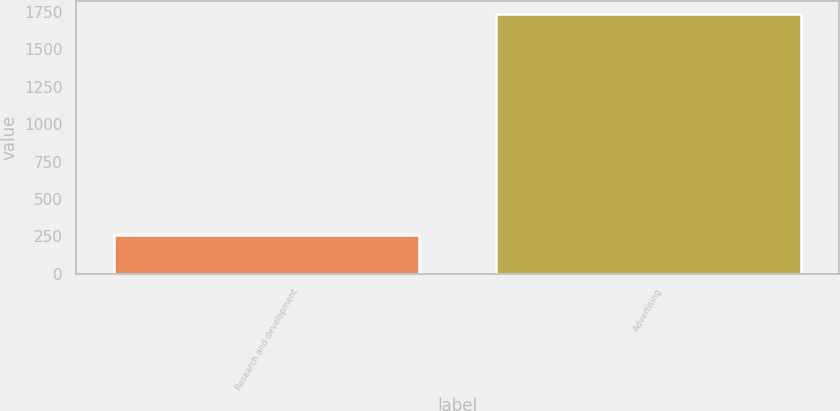<chart> <loc_0><loc_0><loc_500><loc_500><bar_chart><fcel>Research and development<fcel>Advertising<nl><fcel>262<fcel>1734<nl></chart> 